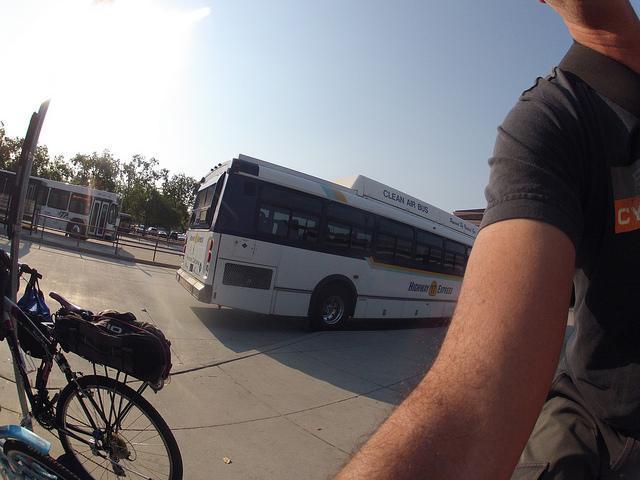How many bicycles are visible in this photo?
Give a very brief answer. 1. How many bikes does he have?
Give a very brief answer. 1. How many officers are in the photo?
Give a very brief answer. 0. How many buses can be seen?
Give a very brief answer. 2. How many bicycles are there?
Give a very brief answer. 2. 